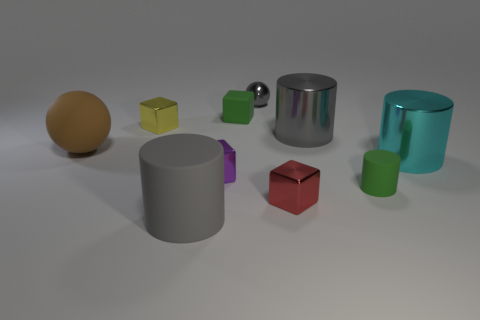Subtract all cyan balls. Subtract all blue cubes. How many balls are left? 2 Subtract all balls. How many objects are left? 8 Subtract 1 green cubes. How many objects are left? 9 Subtract all cyan cylinders. Subtract all big gray rubber spheres. How many objects are left? 9 Add 1 gray metallic balls. How many gray metallic balls are left? 2 Add 9 large gray shiny cylinders. How many large gray shiny cylinders exist? 10 